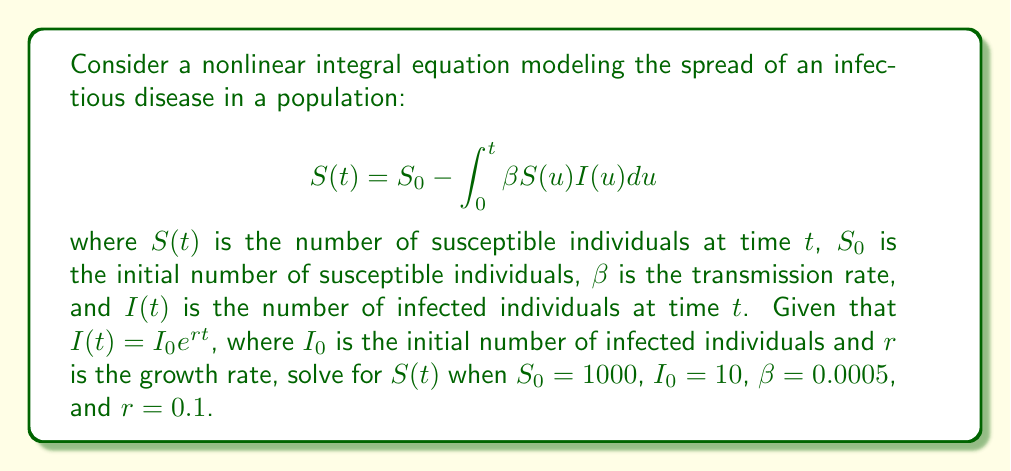Could you help me with this problem? To solve this nonlinear integral equation, we'll follow these steps:

1) First, substitute the given expression for $I(t)$ into the integral equation:

   $$S(t) = 1000 - \int_0^t 0.0005 \cdot S(u) \cdot 10e^{0.1u} du$$

2) Simplify the constant terms:

   $$S(t) = 1000 - 0.005 \int_0^t S(u) e^{0.1u} du$$

3) To solve this equation, we can differentiate both sides with respect to $t$:

   $$\frac{dS}{dt} = -0.005 \cdot S(t) \cdot e^{0.1t}$$

4) This is now a separable differential equation. Rearrange it:

   $$\frac{dS}{S} = -0.005 \cdot e^{0.1t} dt$$

5) Integrate both sides:

   $$\int \frac{dS}{S} = -0.005 \int e^{0.1t} dt$$

   $$\ln|S| = -0.05 \cdot e^{0.1t} + C$$

6) Solve for $S$:

   $$S = A \cdot e^{-0.05 \cdot e^{0.1t}}$$

   where $A$ is a constant of integration.

7) To find $A$, use the initial condition $S(0) = 1000$:

   $$1000 = A \cdot e^{-0.05 \cdot e^0} = A \cdot e^{-0.05}$$

   $$A = 1000 \cdot e^{0.05}$$

8) Therefore, the final solution is:

   $$S(t) = 1000 \cdot e^{0.05} \cdot e^{-0.05 \cdot e^{0.1t}}$$
Answer: $S(t) = 1000 \cdot e^{0.05} \cdot e^{-0.05 \cdot e^{0.1t}}$ 